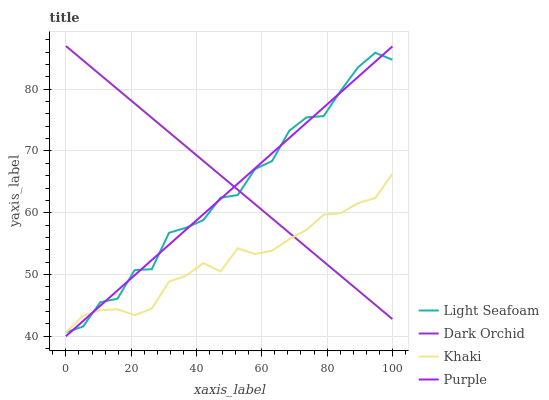Does Light Seafoam have the minimum area under the curve?
Answer yes or no. No. Does Light Seafoam have the maximum area under the curve?
Answer yes or no. No. Is Khaki the smoothest?
Answer yes or no. No. Is Khaki the roughest?
Answer yes or no. No. Does Light Seafoam have the lowest value?
Answer yes or no. No. Does Light Seafoam have the highest value?
Answer yes or no. No. 